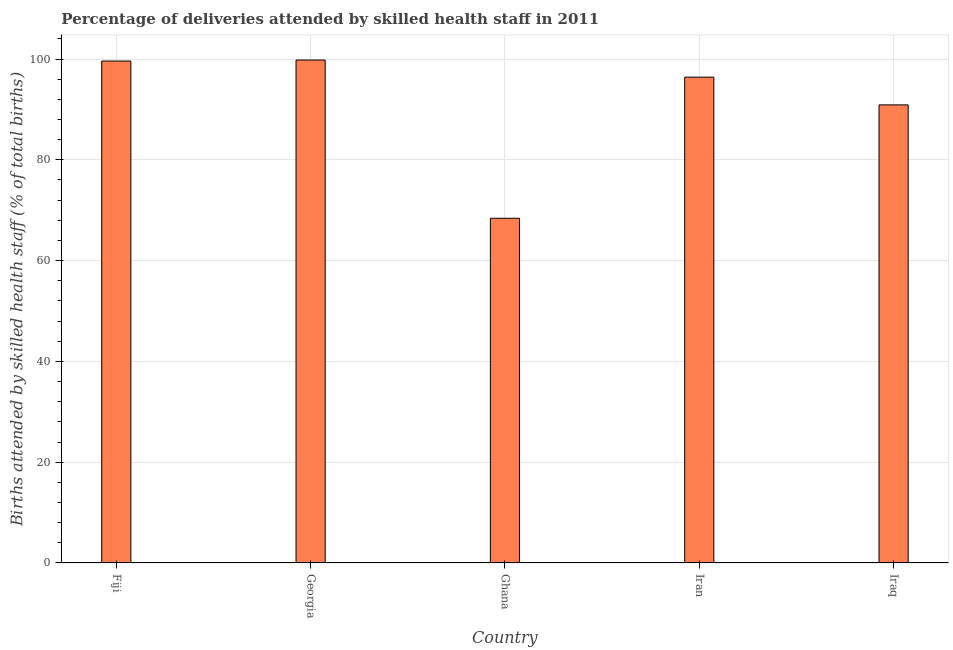Does the graph contain grids?
Give a very brief answer. Yes. What is the title of the graph?
Offer a very short reply. Percentage of deliveries attended by skilled health staff in 2011. What is the label or title of the Y-axis?
Your response must be concise. Births attended by skilled health staff (% of total births). What is the number of births attended by skilled health staff in Georgia?
Your response must be concise. 99.8. Across all countries, what is the maximum number of births attended by skilled health staff?
Provide a succinct answer. 99.8. Across all countries, what is the minimum number of births attended by skilled health staff?
Keep it short and to the point. 68.4. In which country was the number of births attended by skilled health staff maximum?
Offer a very short reply. Georgia. What is the sum of the number of births attended by skilled health staff?
Offer a very short reply. 455.1. What is the difference between the number of births attended by skilled health staff in Fiji and Ghana?
Make the answer very short. 31.2. What is the average number of births attended by skilled health staff per country?
Offer a terse response. 91.02. What is the median number of births attended by skilled health staff?
Ensure brevity in your answer.  96.4. What is the ratio of the number of births attended by skilled health staff in Iran to that in Iraq?
Your answer should be compact. 1.06. Is the number of births attended by skilled health staff in Ghana less than that in Iraq?
Your answer should be very brief. Yes. What is the difference between the highest and the second highest number of births attended by skilled health staff?
Your response must be concise. 0.2. Is the sum of the number of births attended by skilled health staff in Georgia and Ghana greater than the maximum number of births attended by skilled health staff across all countries?
Provide a succinct answer. Yes. What is the difference between the highest and the lowest number of births attended by skilled health staff?
Your answer should be very brief. 31.4. In how many countries, is the number of births attended by skilled health staff greater than the average number of births attended by skilled health staff taken over all countries?
Offer a very short reply. 3. How many bars are there?
Keep it short and to the point. 5. Are all the bars in the graph horizontal?
Your answer should be compact. No. Are the values on the major ticks of Y-axis written in scientific E-notation?
Offer a very short reply. No. What is the Births attended by skilled health staff (% of total births) of Fiji?
Keep it short and to the point. 99.6. What is the Births attended by skilled health staff (% of total births) in Georgia?
Offer a very short reply. 99.8. What is the Births attended by skilled health staff (% of total births) in Ghana?
Offer a very short reply. 68.4. What is the Births attended by skilled health staff (% of total births) in Iran?
Keep it short and to the point. 96.4. What is the Births attended by skilled health staff (% of total births) of Iraq?
Your answer should be very brief. 90.9. What is the difference between the Births attended by skilled health staff (% of total births) in Fiji and Georgia?
Your answer should be very brief. -0.2. What is the difference between the Births attended by skilled health staff (% of total births) in Fiji and Ghana?
Keep it short and to the point. 31.2. What is the difference between the Births attended by skilled health staff (% of total births) in Georgia and Ghana?
Your response must be concise. 31.4. What is the difference between the Births attended by skilled health staff (% of total births) in Georgia and Iran?
Give a very brief answer. 3.4. What is the difference between the Births attended by skilled health staff (% of total births) in Georgia and Iraq?
Ensure brevity in your answer.  8.9. What is the difference between the Births attended by skilled health staff (% of total births) in Ghana and Iran?
Your response must be concise. -28. What is the difference between the Births attended by skilled health staff (% of total births) in Ghana and Iraq?
Your answer should be compact. -22.5. What is the ratio of the Births attended by skilled health staff (% of total births) in Fiji to that in Georgia?
Provide a short and direct response. 1. What is the ratio of the Births attended by skilled health staff (% of total births) in Fiji to that in Ghana?
Provide a succinct answer. 1.46. What is the ratio of the Births attended by skilled health staff (% of total births) in Fiji to that in Iran?
Ensure brevity in your answer.  1.03. What is the ratio of the Births attended by skilled health staff (% of total births) in Fiji to that in Iraq?
Your response must be concise. 1.1. What is the ratio of the Births attended by skilled health staff (% of total births) in Georgia to that in Ghana?
Make the answer very short. 1.46. What is the ratio of the Births attended by skilled health staff (% of total births) in Georgia to that in Iran?
Provide a short and direct response. 1.03. What is the ratio of the Births attended by skilled health staff (% of total births) in Georgia to that in Iraq?
Make the answer very short. 1.1. What is the ratio of the Births attended by skilled health staff (% of total births) in Ghana to that in Iran?
Offer a very short reply. 0.71. What is the ratio of the Births attended by skilled health staff (% of total births) in Ghana to that in Iraq?
Ensure brevity in your answer.  0.75. What is the ratio of the Births attended by skilled health staff (% of total births) in Iran to that in Iraq?
Offer a very short reply. 1.06. 